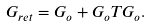<formula> <loc_0><loc_0><loc_500><loc_500>G _ { r e t } = G _ { o } + G _ { o } T G _ { o } .</formula> 